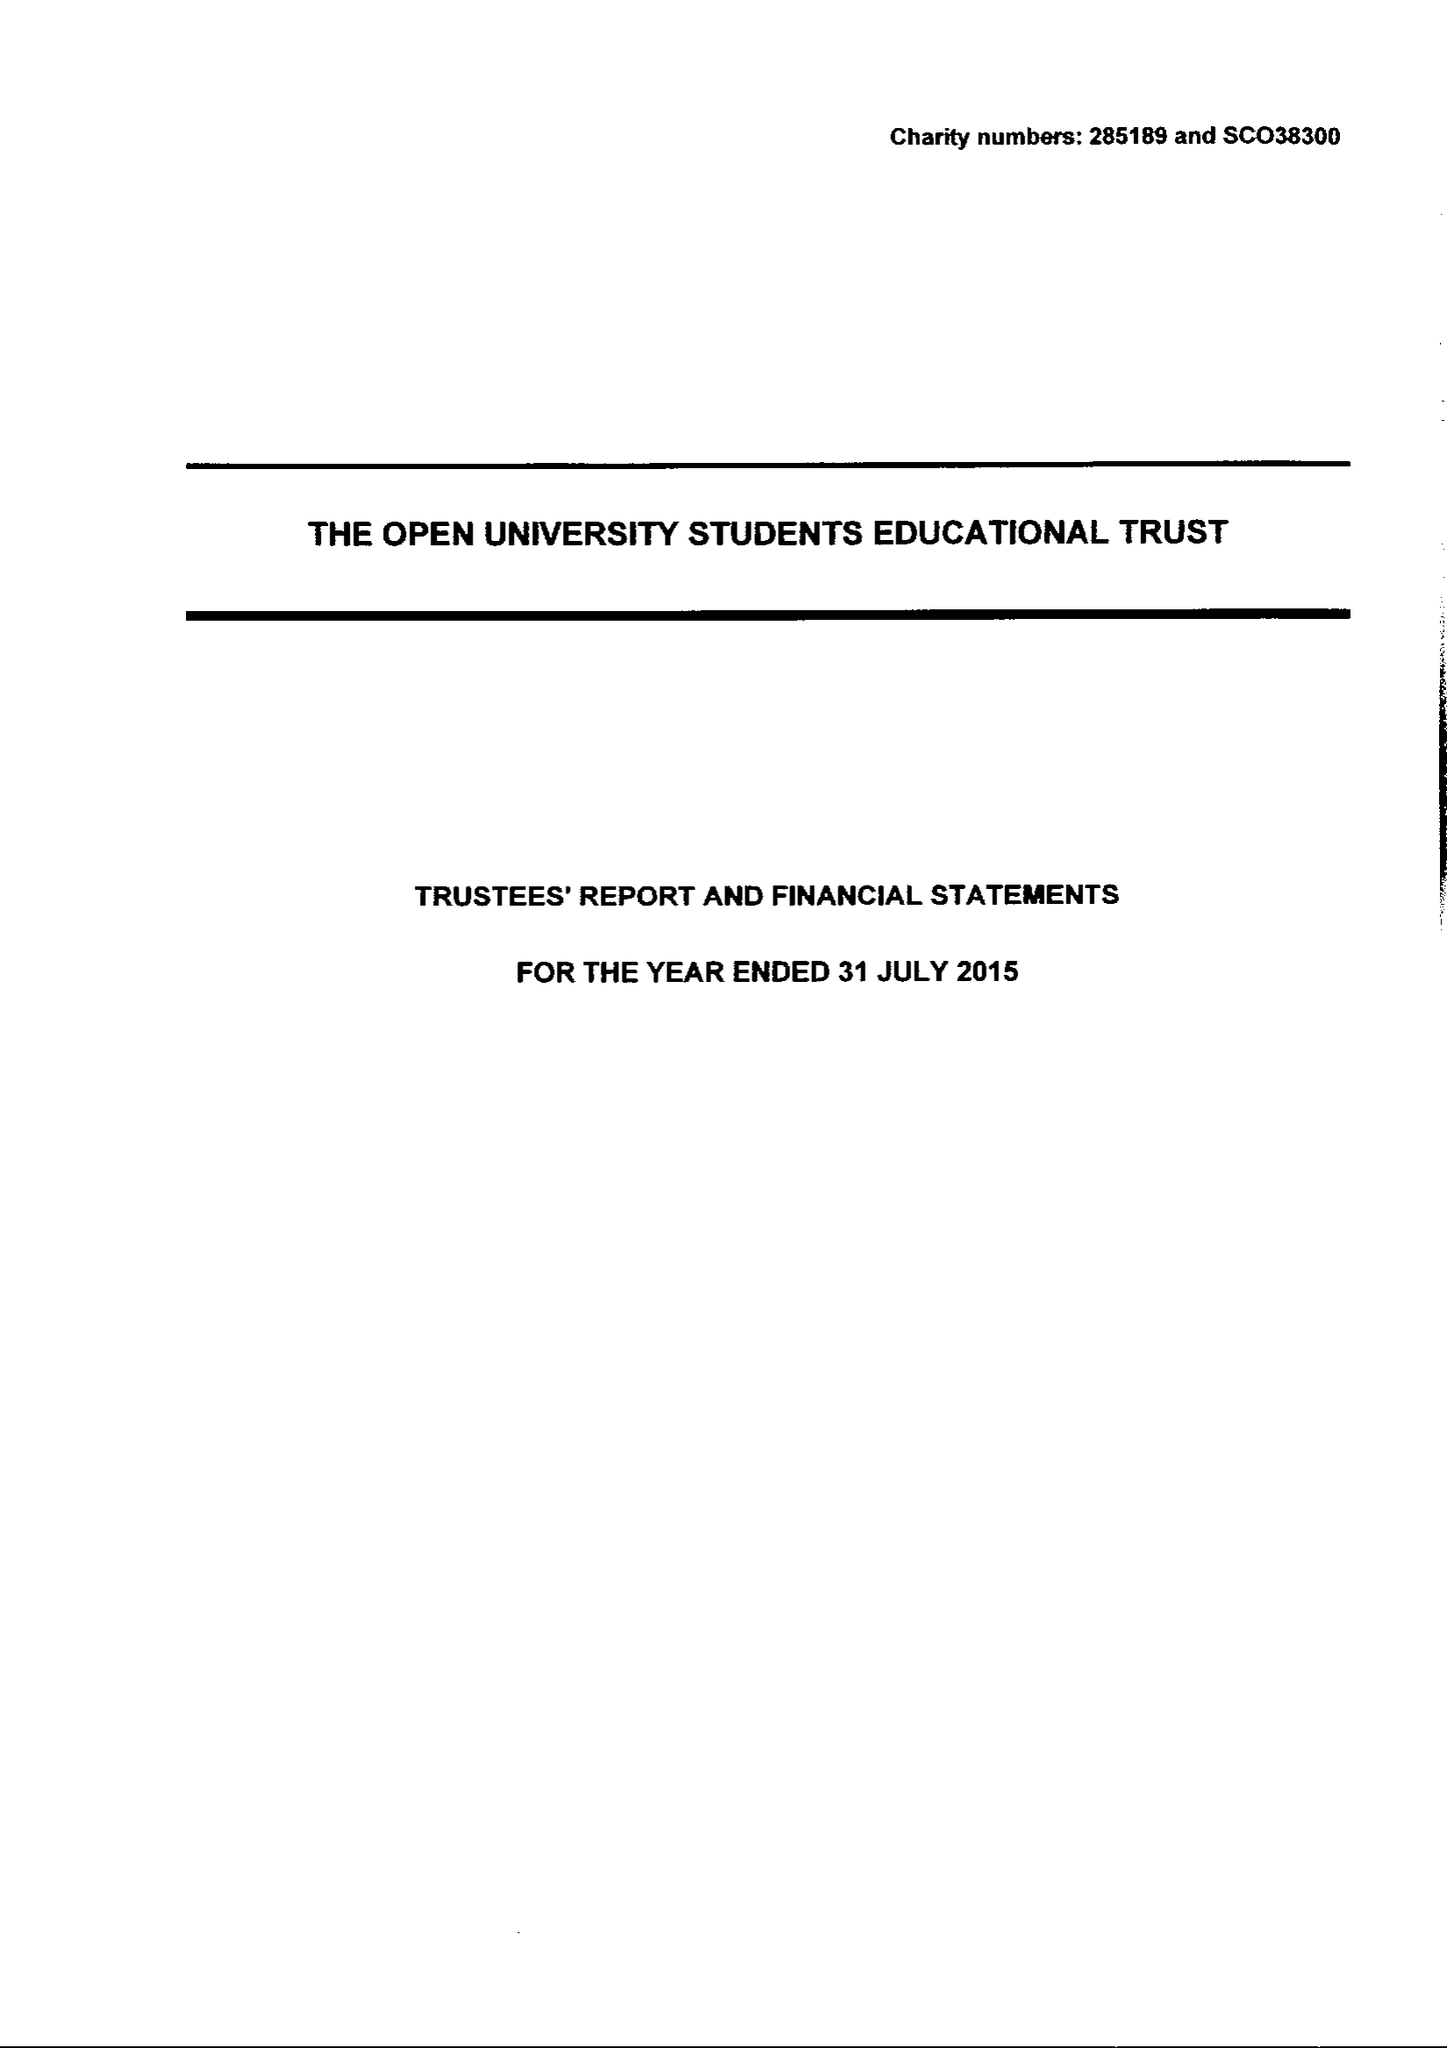What is the value for the address__postcode?
Answer the question using a single word or phrase. MK7 6BE 